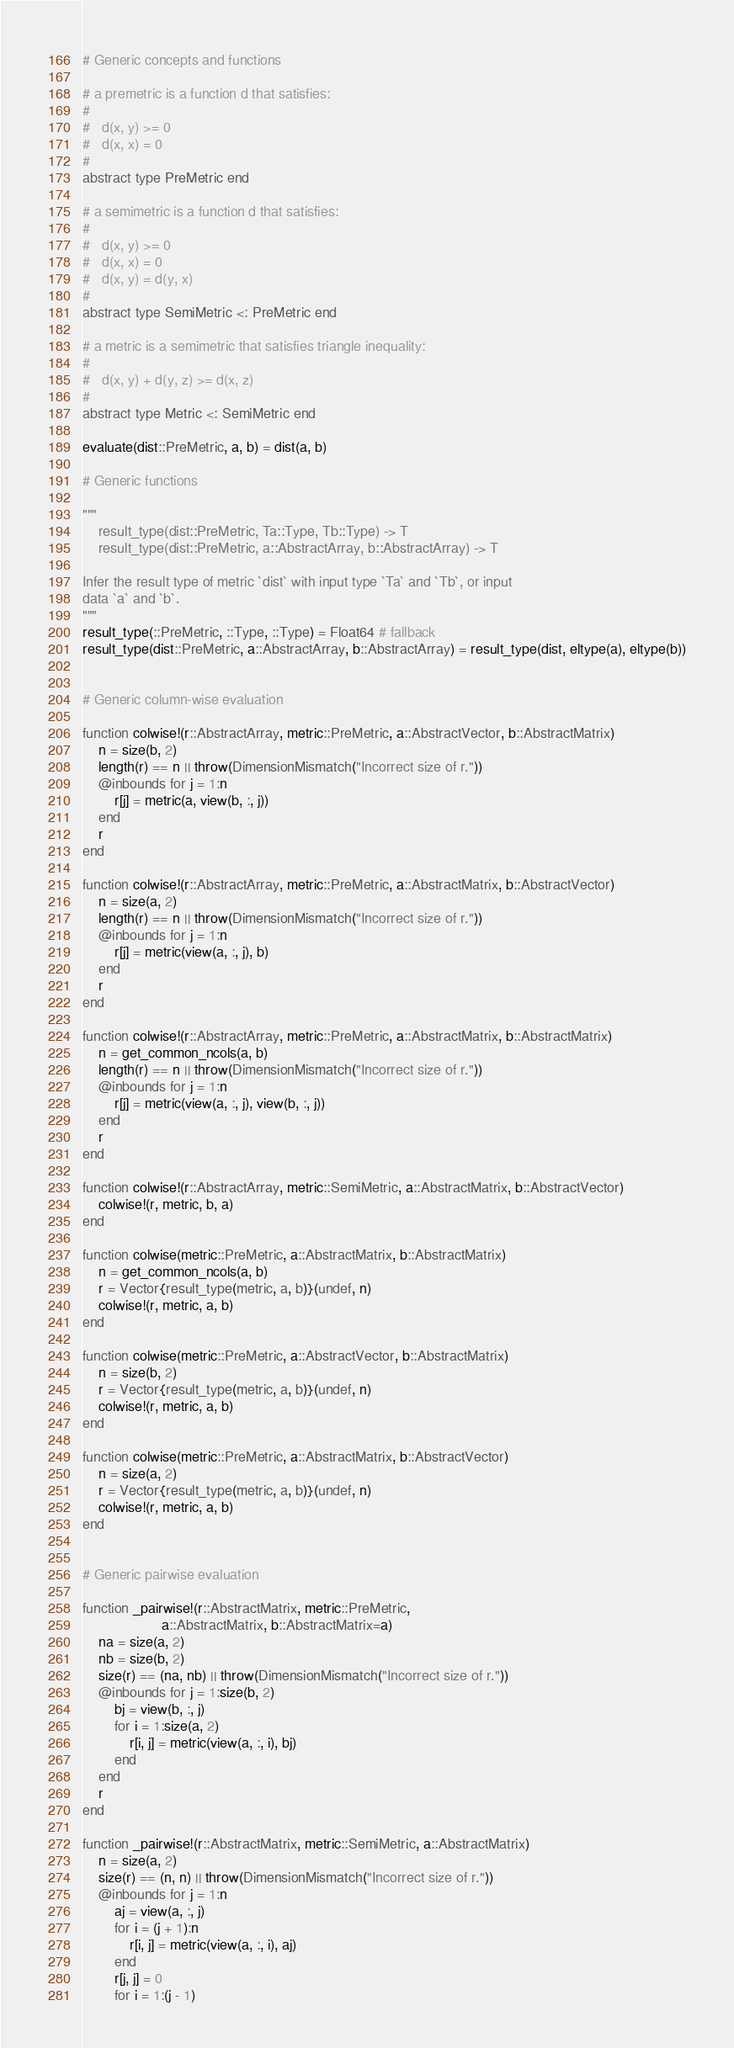Convert code to text. <code><loc_0><loc_0><loc_500><loc_500><_Julia_># Generic concepts and functions

# a premetric is a function d that satisfies:
#
#   d(x, y) >= 0
#   d(x, x) = 0
#
abstract type PreMetric end

# a semimetric is a function d that satisfies:
#
#   d(x, y) >= 0
#   d(x, x) = 0
#   d(x, y) = d(y, x)
#
abstract type SemiMetric <: PreMetric end

# a metric is a semimetric that satisfies triangle inequality:
#
#   d(x, y) + d(y, z) >= d(x, z)
#
abstract type Metric <: SemiMetric end

evaluate(dist::PreMetric, a, b) = dist(a, b)

# Generic functions

"""
    result_type(dist::PreMetric, Ta::Type, Tb::Type) -> T
    result_type(dist::PreMetric, a::AbstractArray, b::AbstractArray) -> T

Infer the result type of metric `dist` with input type `Ta` and `Tb`, or input
data `a` and `b`.
"""
result_type(::PreMetric, ::Type, ::Type) = Float64 # fallback
result_type(dist::PreMetric, a::AbstractArray, b::AbstractArray) = result_type(dist, eltype(a), eltype(b))


# Generic column-wise evaluation

function colwise!(r::AbstractArray, metric::PreMetric, a::AbstractVector, b::AbstractMatrix)
    n = size(b, 2)
    length(r) == n || throw(DimensionMismatch("Incorrect size of r."))
    @inbounds for j = 1:n
        r[j] = metric(a, view(b, :, j))
    end
    r
end

function colwise!(r::AbstractArray, metric::PreMetric, a::AbstractMatrix, b::AbstractVector)
    n = size(a, 2)
    length(r) == n || throw(DimensionMismatch("Incorrect size of r."))
    @inbounds for j = 1:n
        r[j] = metric(view(a, :, j), b)
    end
    r
end

function colwise!(r::AbstractArray, metric::PreMetric, a::AbstractMatrix, b::AbstractMatrix)
    n = get_common_ncols(a, b)
    length(r) == n || throw(DimensionMismatch("Incorrect size of r."))
    @inbounds for j = 1:n
        r[j] = metric(view(a, :, j), view(b, :, j))
    end
    r
end

function colwise!(r::AbstractArray, metric::SemiMetric, a::AbstractMatrix, b::AbstractVector)
    colwise!(r, metric, b, a)
end

function colwise(metric::PreMetric, a::AbstractMatrix, b::AbstractMatrix)
    n = get_common_ncols(a, b)
    r = Vector{result_type(metric, a, b)}(undef, n)
    colwise!(r, metric, a, b)
end

function colwise(metric::PreMetric, a::AbstractVector, b::AbstractMatrix)
    n = size(b, 2)
    r = Vector{result_type(metric, a, b)}(undef, n)
    colwise!(r, metric, a, b)
end

function colwise(metric::PreMetric, a::AbstractMatrix, b::AbstractVector)
    n = size(a, 2)
    r = Vector{result_type(metric, a, b)}(undef, n)
    colwise!(r, metric, a, b)
end


# Generic pairwise evaluation

function _pairwise!(r::AbstractMatrix, metric::PreMetric,
                    a::AbstractMatrix, b::AbstractMatrix=a)
    na = size(a, 2)
    nb = size(b, 2)
    size(r) == (na, nb) || throw(DimensionMismatch("Incorrect size of r."))
    @inbounds for j = 1:size(b, 2)
        bj = view(b, :, j)
        for i = 1:size(a, 2)
            r[i, j] = metric(view(a, :, i), bj)
        end
    end
    r
end

function _pairwise!(r::AbstractMatrix, metric::SemiMetric, a::AbstractMatrix)
    n = size(a, 2)
    size(r) == (n, n) || throw(DimensionMismatch("Incorrect size of r."))
    @inbounds for j = 1:n
        aj = view(a, :, j)
        for i = (j + 1):n
            r[i, j] = metric(view(a, :, i), aj)
        end
        r[j, j] = 0
        for i = 1:(j - 1)</code> 